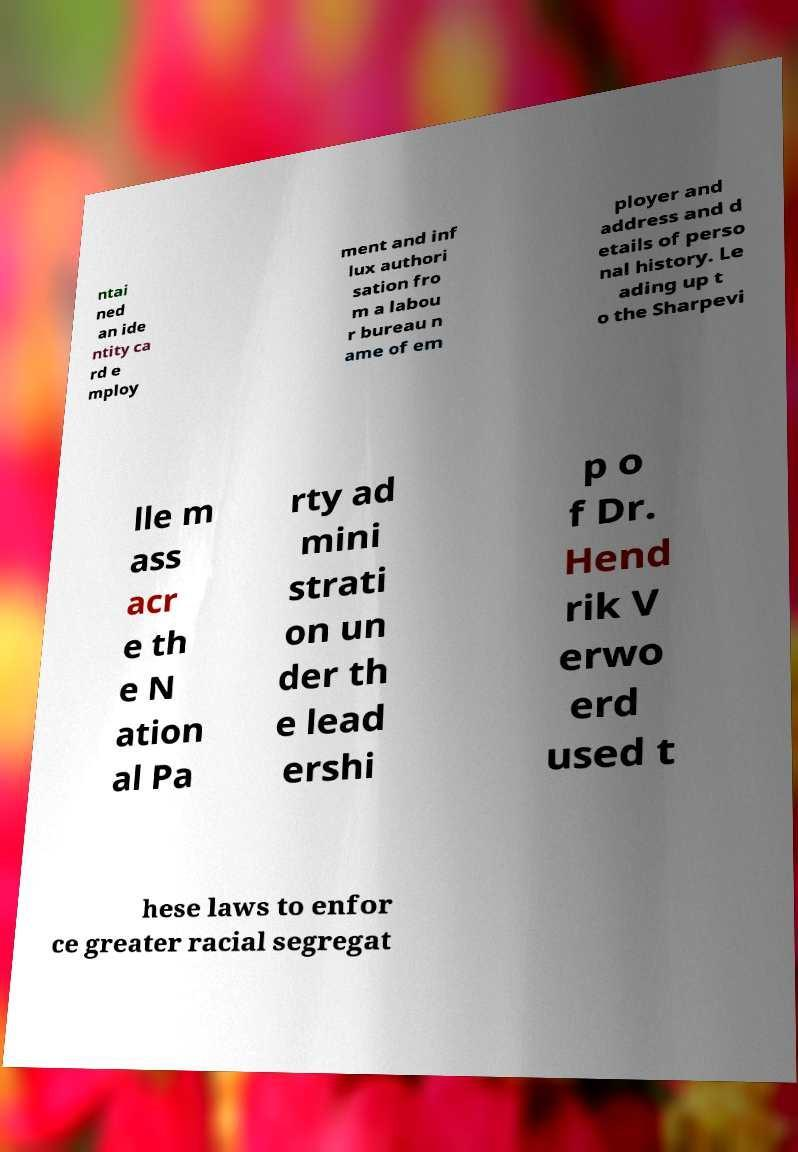Please read and relay the text visible in this image. What does it say? ntai ned an ide ntity ca rd e mploy ment and inf lux authori sation fro m a labou r bureau n ame of em ployer and address and d etails of perso nal history. Le ading up t o the Sharpevi lle m ass acr e th e N ation al Pa rty ad mini strati on un der th e lead ershi p o f Dr. Hend rik V erwo erd used t hese laws to enfor ce greater racial segregat 